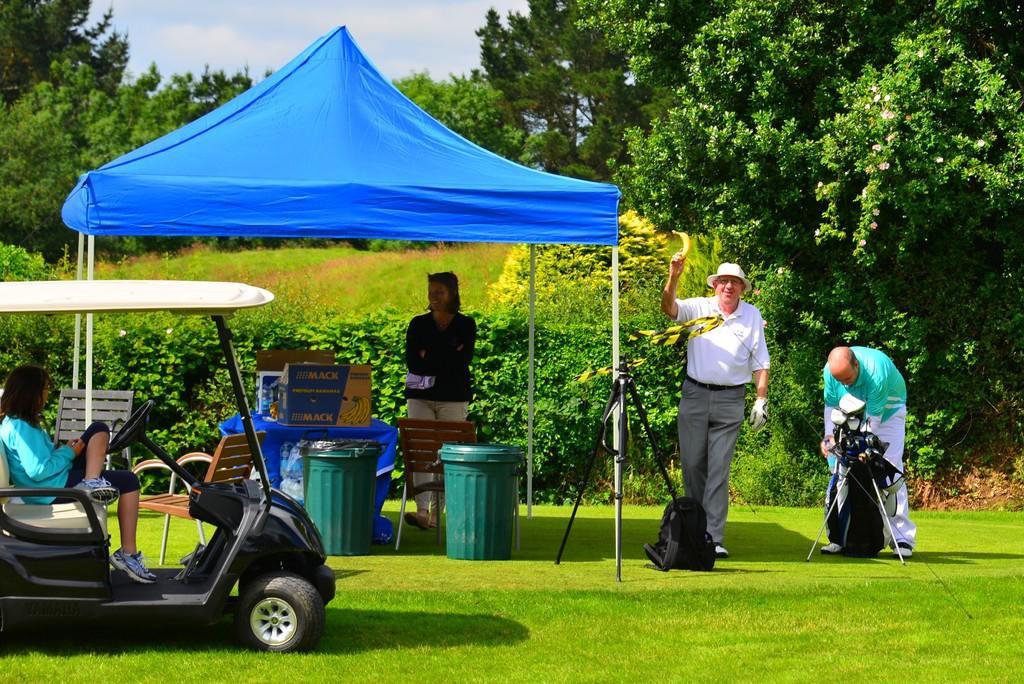Describe this image in one or two sentences. In this picture we can see three persons standing here, on the left side there is a vehicle, we can see a person sitting in the vehicle, at the bottom there is grass, we can see a dustbins here, in the background there are trees, there is a tent here, there is the sky at the top of the picture, we can see a bag and a tripod here, there is a cardboard box and a chair here. 